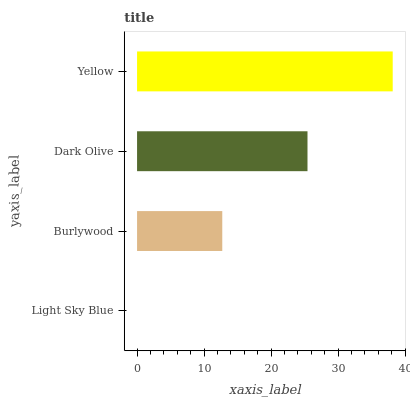Is Light Sky Blue the minimum?
Answer yes or no. Yes. Is Yellow the maximum?
Answer yes or no. Yes. Is Burlywood the minimum?
Answer yes or no. No. Is Burlywood the maximum?
Answer yes or no. No. Is Burlywood greater than Light Sky Blue?
Answer yes or no. Yes. Is Light Sky Blue less than Burlywood?
Answer yes or no. Yes. Is Light Sky Blue greater than Burlywood?
Answer yes or no. No. Is Burlywood less than Light Sky Blue?
Answer yes or no. No. Is Dark Olive the high median?
Answer yes or no. Yes. Is Burlywood the low median?
Answer yes or no. Yes. Is Yellow the high median?
Answer yes or no. No. Is Light Sky Blue the low median?
Answer yes or no. No. 